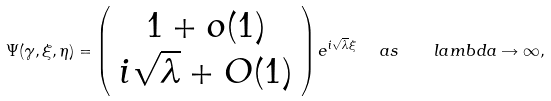<formula> <loc_0><loc_0><loc_500><loc_500>\Psi ( \gamma , \xi , \eta ) = \left ( \begin{array} { c } 1 + o ( 1 ) \\ i \sqrt { \lambda } + O ( 1 ) \end{array} \right ) e ^ { i \sqrt { \lambda } \xi } \ \ a s \quad l a m b d a \rightarrow \infty ,</formula> 